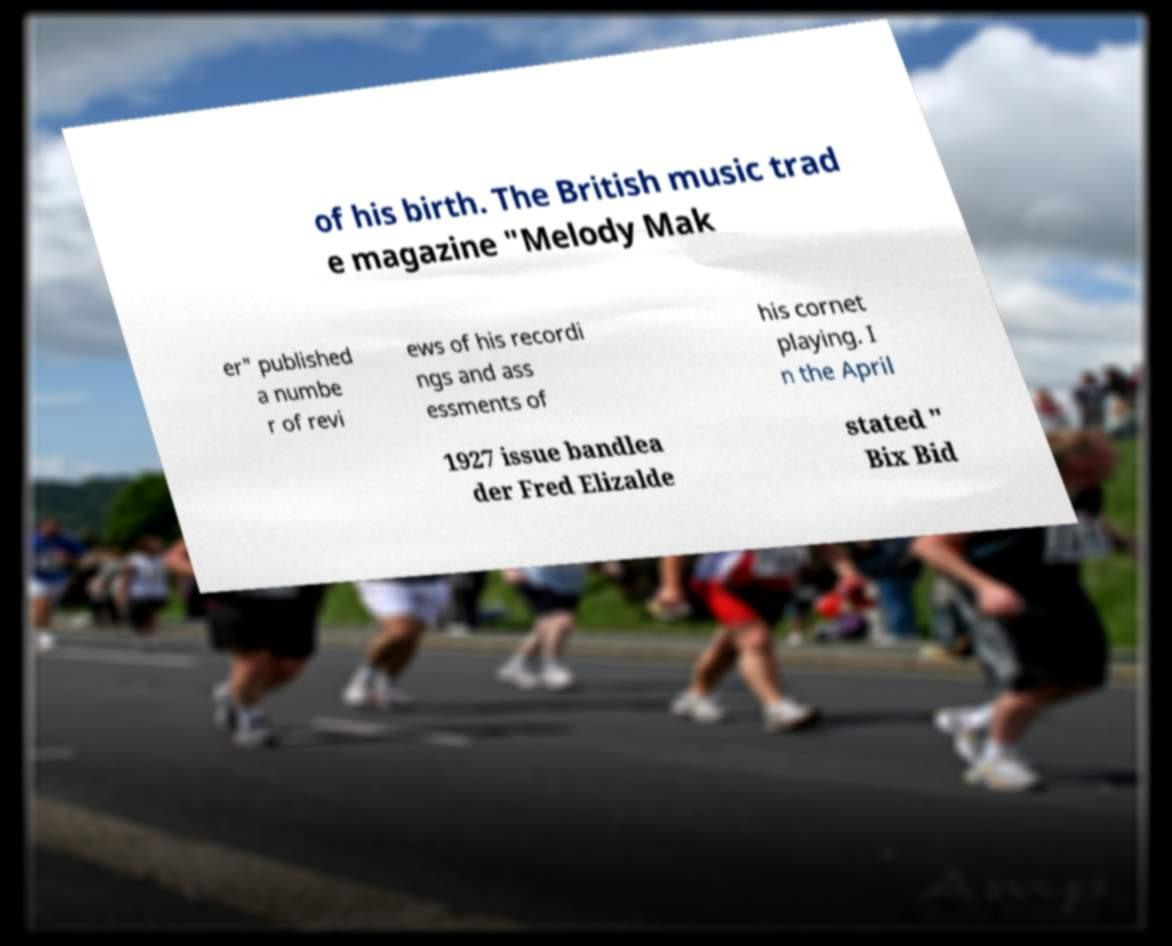I need the written content from this picture converted into text. Can you do that? of his birth. The British music trad e magazine "Melody Mak er" published a numbe r of revi ews of his recordi ngs and ass essments of his cornet playing. I n the April 1927 issue bandlea der Fred Elizalde stated " Bix Bid 